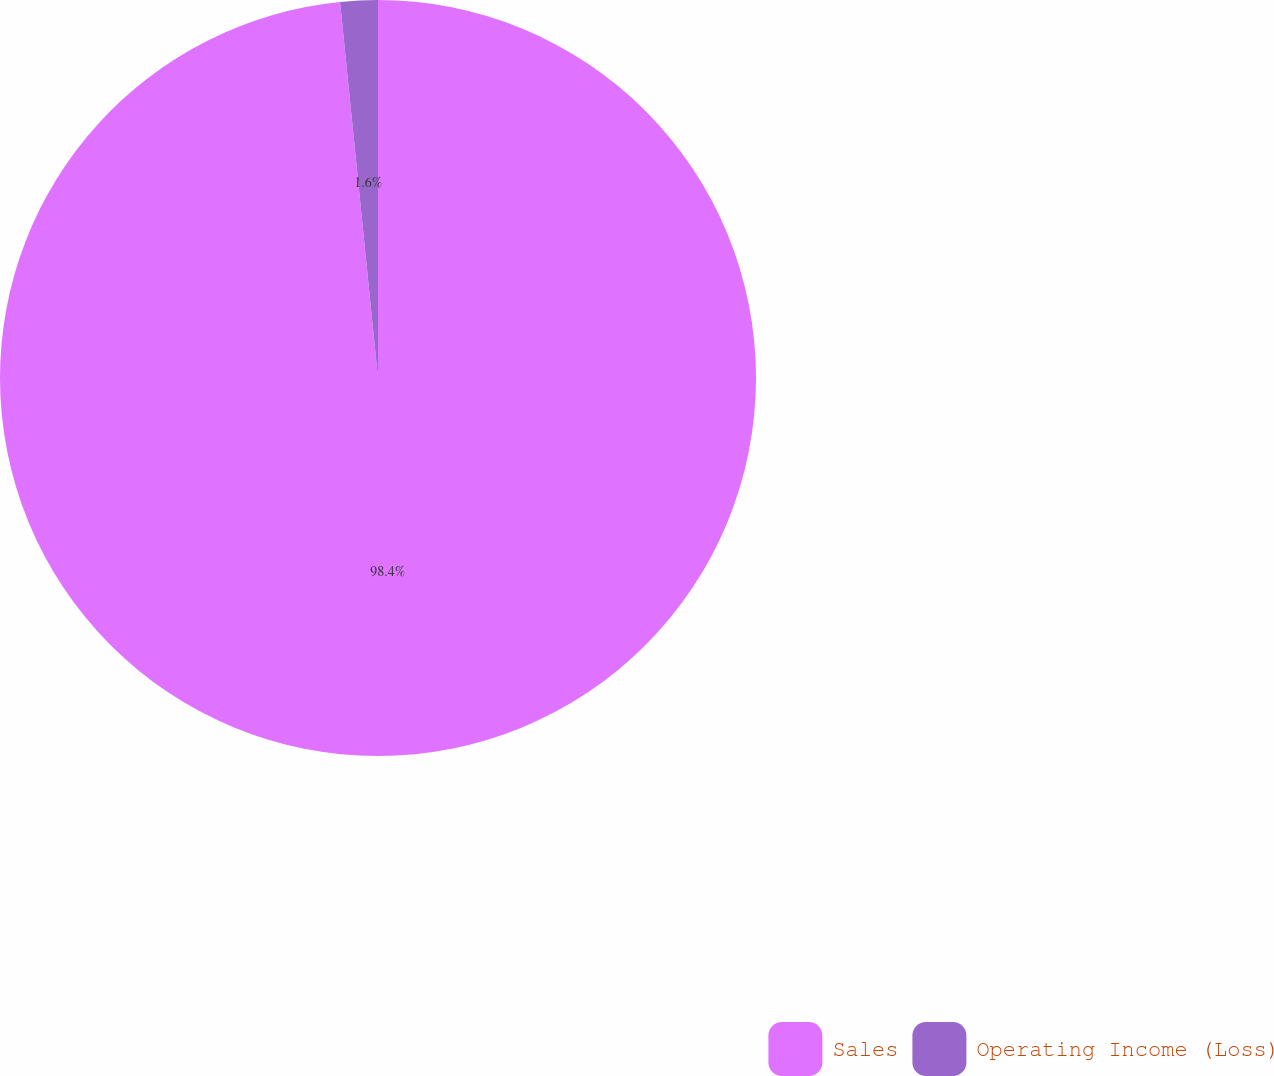Convert chart to OTSL. <chart><loc_0><loc_0><loc_500><loc_500><pie_chart><fcel>Sales<fcel>Operating Income (Loss)<nl><fcel>98.4%<fcel>1.6%<nl></chart> 